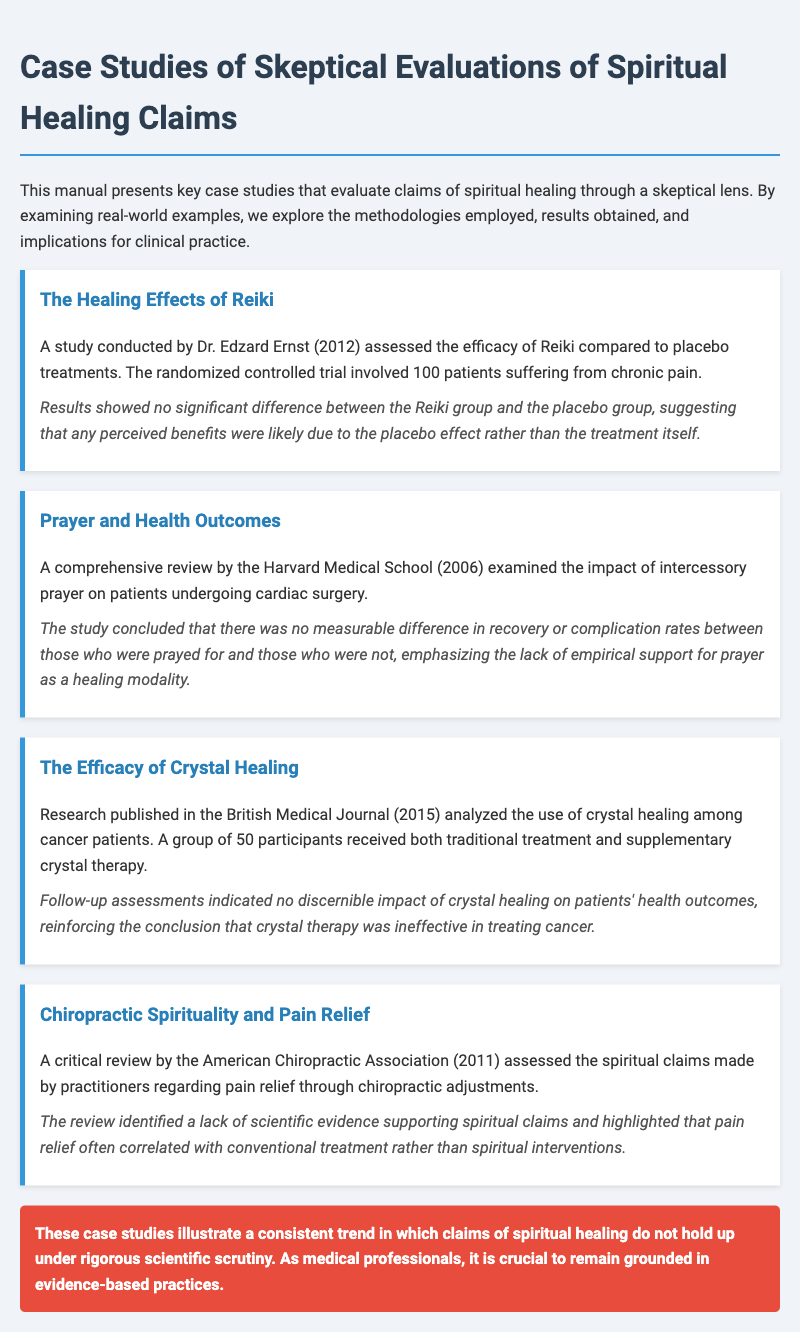What was the year of the Reiki study? The document states that the study conducted by Dr. Edzard Ernst on Reiki was in 2012.
Answer: 2012 How many patients were involved in the prayer study? The Harvard Medical School review assessed patients undergoing cardiac surgery, but the document does not specify a number for this study.
Answer: Not specified What did the crystal healing study analyze? The research published in the British Medical Journal analyzed the use of crystal healing among cancer patients.
Answer: Crystal healing Who conducted the review on chiropractic spirituality? The review was conducted by the American Chiropractic Association.
Answer: American Chiropractic Association What was the main conclusion from the case studies presented? The manual concludes that claims of spiritual healing do not hold up under rigorous scientific scrutiny.
Answer: Claims do not hold up What type of trial was used in the Reiki study? The Reiki study mentioned was a randomized controlled trial.
Answer: Randomized controlled trial How many participants were in the crystal healing study? The research on crystal healing involved a group of 50 participants.
Answer: 50 participants What is the publication year of the crystal healing study? The document states that the study analyzed in the British Medical Journal was published in 2015.
Answer: 2015 